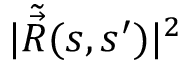<formula> <loc_0><loc_0><loc_500><loc_500>| \tilde { \vec { R } } ( s , s ^ { \prime } ) | ^ { 2 }</formula> 